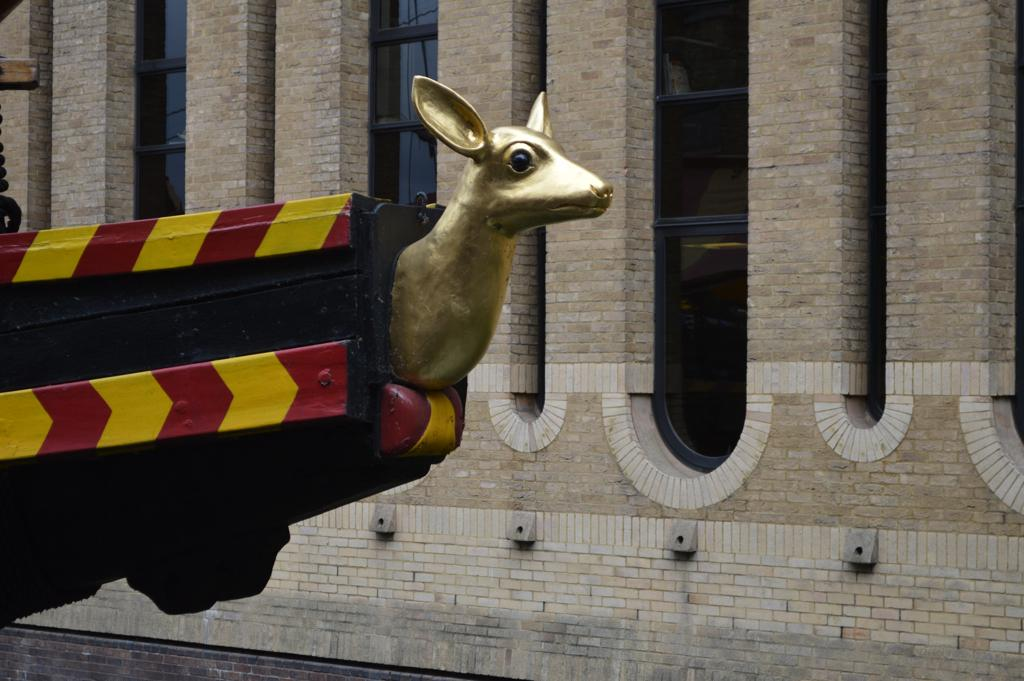What is the main subject of the image? The main subject of the image is a golden color statue. How is the statue connected to another object? The statue is attached to an object that is hanged with a chain. What can be seen in the background of the image? There is a building in the background of the image. What type of windows does the building have? The building has glass windows. How many friends are participating in the competition in the image? There is no competition or friends present in the image; it features a golden color statue attached to an object that is hanged with a chain, with a building in the background. Can you provide a guide on how to reach the statue in the image? There is no need for a guide in the image, as it is a static representation of a statue and its surroundings. 